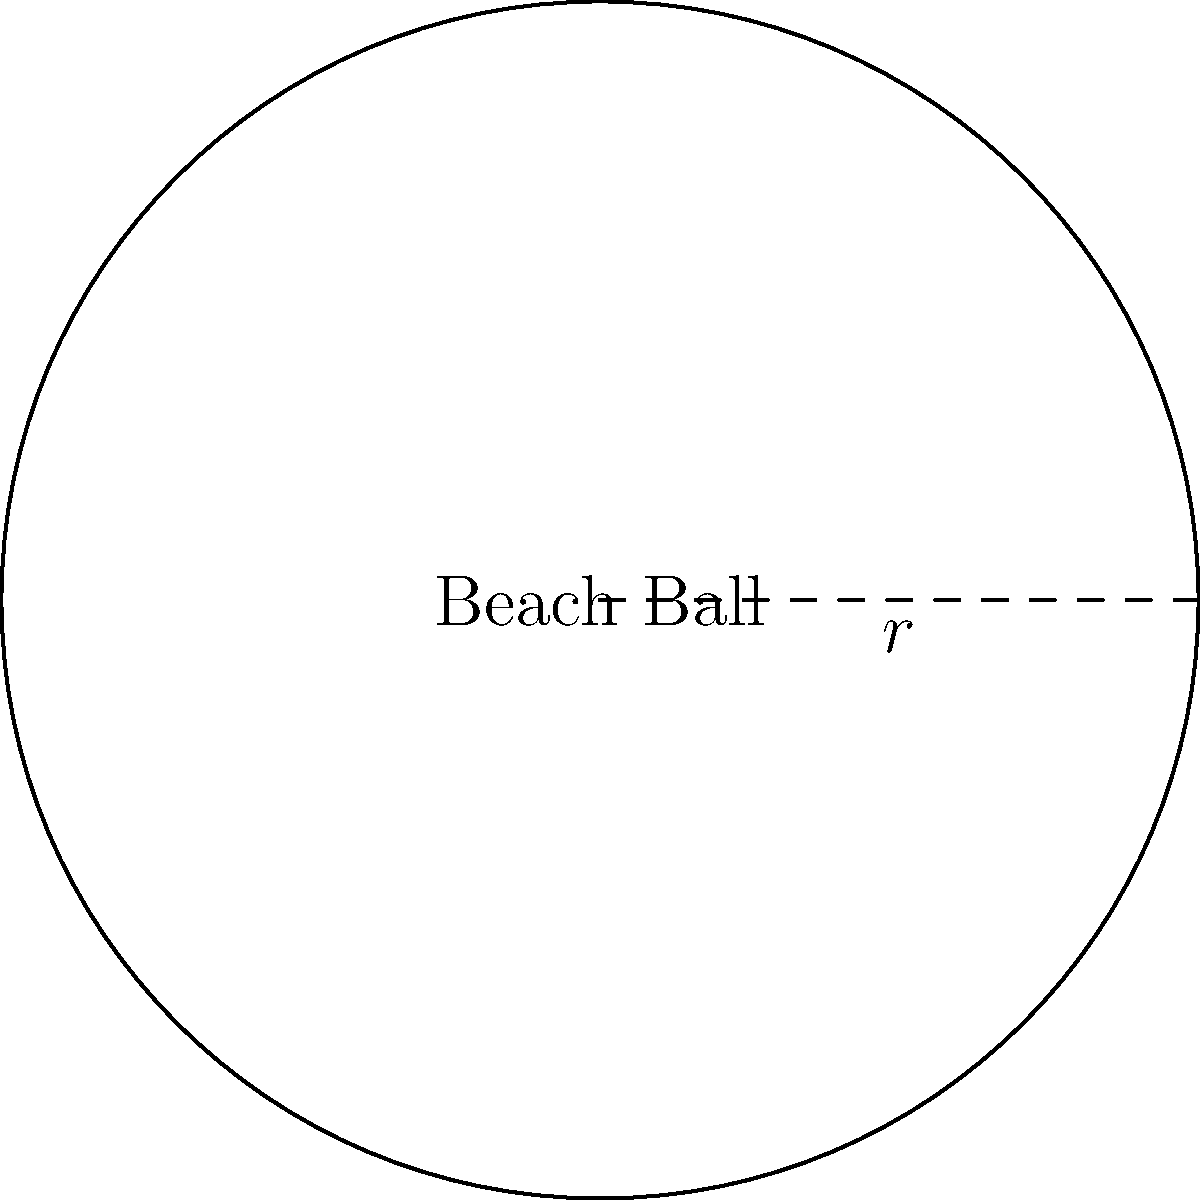While recommending photography spots at Bournemouth Beach, you notice a perfectly spherical beach ball with a radius of 30 cm. What is the surface area of this beach ball? To find the surface area of a sphere, we use the formula:

$$ A = 4\pi r^2 $$

Where:
- $A$ is the surface area
- $r$ is the radius of the sphere

Given:
- Radius $(r) = 30$ cm

Step 1: Substitute the radius into the formula.
$$ A = 4\pi (30\text{ cm})^2 $$

Step 2: Calculate the square of the radius.
$$ A = 4\pi (900\text{ cm}^2) $$

Step 3: Multiply by $4\pi$.
$$ A = 3600\pi\text{ cm}^2 $$

Step 4: Calculate the final result (rounded to two decimal places).
$$ A \approx 11,309.73\text{ cm}^2 $$

Therefore, the surface area of the beach ball is approximately 11,309.73 square centimeters.
Answer: $11,309.73\text{ cm}^2$ 